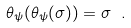<formula> <loc_0><loc_0><loc_500><loc_500>\theta _ { \psi } ( \theta _ { \psi } ( \sigma ) ) = \sigma \ .</formula> 